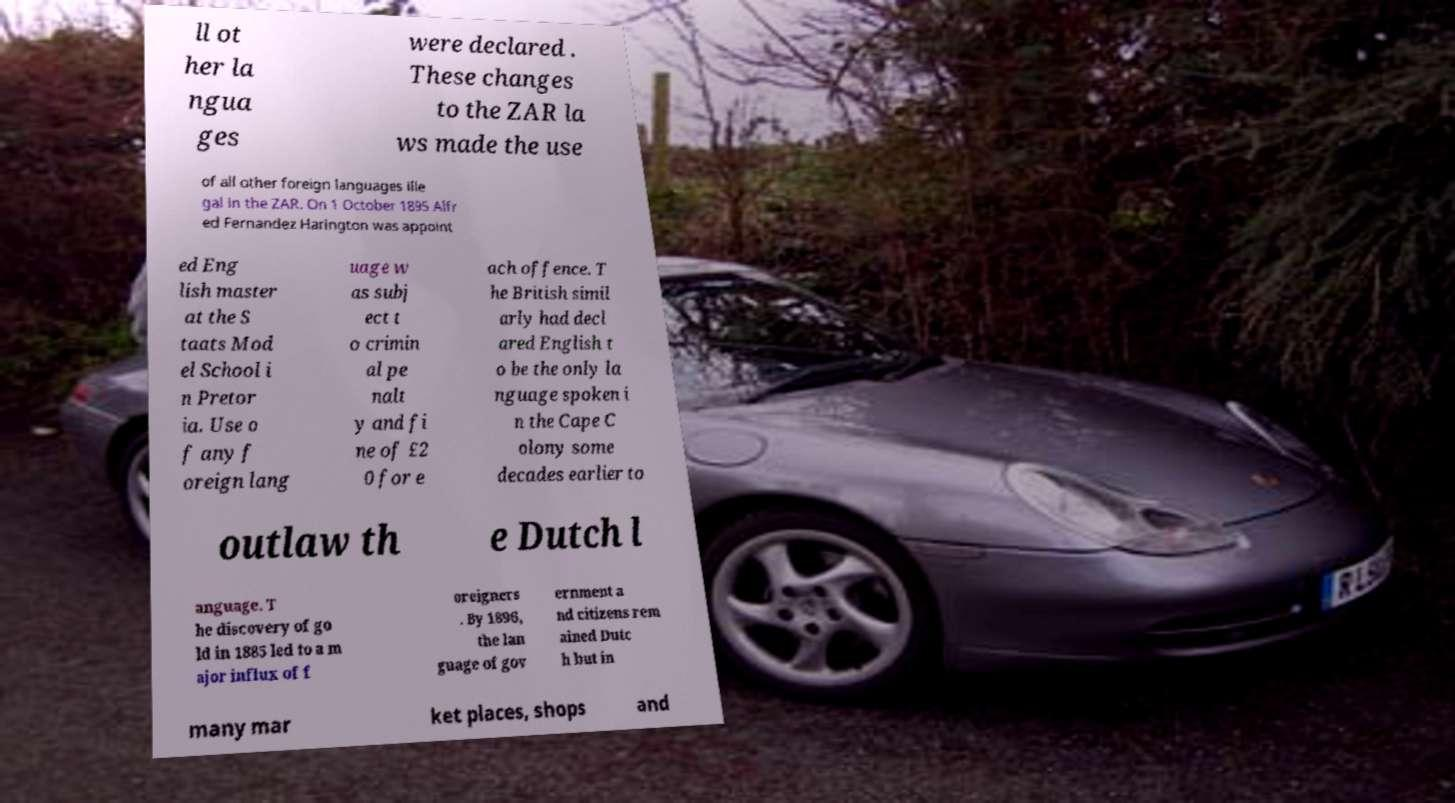Could you extract and type out the text from this image? ll ot her la ngua ges were declared . These changes to the ZAR la ws made the use of all other foreign languages ille gal in the ZAR. On 1 October 1895 Alfr ed Fernandez Harington was appoint ed Eng lish master at the S taats Mod el School i n Pretor ia. Use o f any f oreign lang uage w as subj ect t o crimin al pe nalt y and fi ne of £2 0 for e ach offence. T he British simil arly had decl ared English t o be the only la nguage spoken i n the Cape C olony some decades earlier to outlaw th e Dutch l anguage. T he discovery of go ld in 1885 led to a m ajor influx of f oreigners . By 1896, the lan guage of gov ernment a nd citizens rem ained Dutc h but in many mar ket places, shops and 